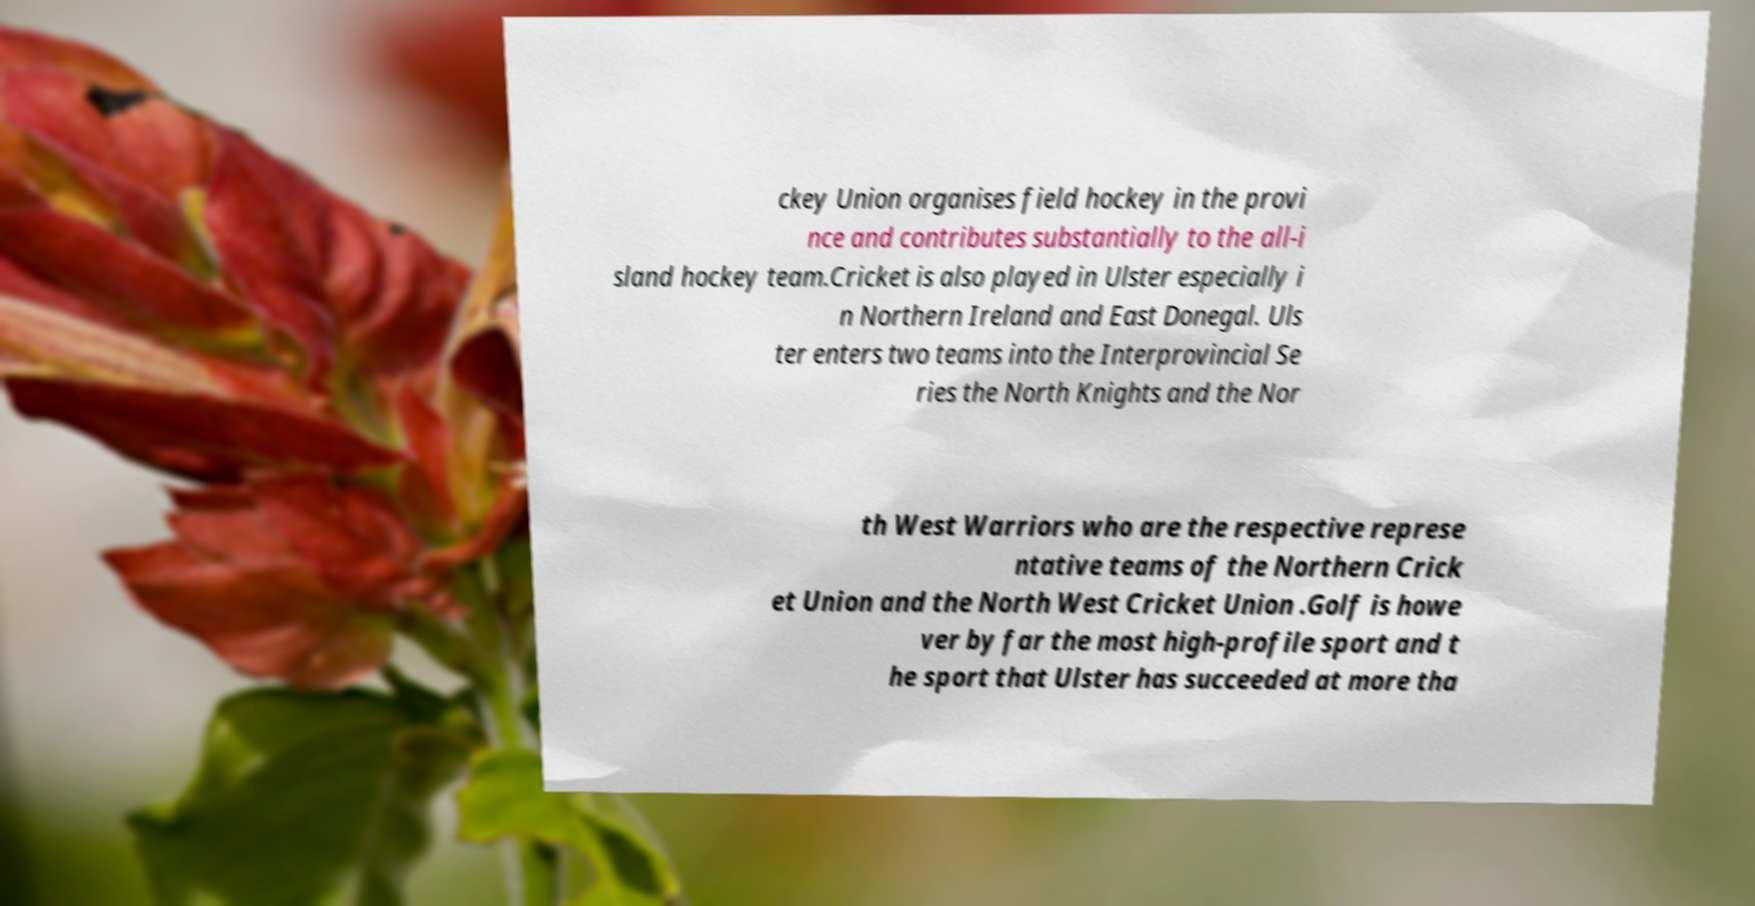Can you accurately transcribe the text from the provided image for me? ckey Union organises field hockey in the provi nce and contributes substantially to the all-i sland hockey team.Cricket is also played in Ulster especially i n Northern Ireland and East Donegal. Uls ter enters two teams into the Interprovincial Se ries the North Knights and the Nor th West Warriors who are the respective represe ntative teams of the Northern Crick et Union and the North West Cricket Union .Golf is howe ver by far the most high-profile sport and t he sport that Ulster has succeeded at more tha 